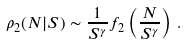<formula> <loc_0><loc_0><loc_500><loc_500>\rho _ { 2 } ( N | S ) \sim \frac { 1 } { S ^ { \gamma } } f _ { 2 } \left ( \frac { N } { S ^ { \gamma } } \right ) \, .</formula> 